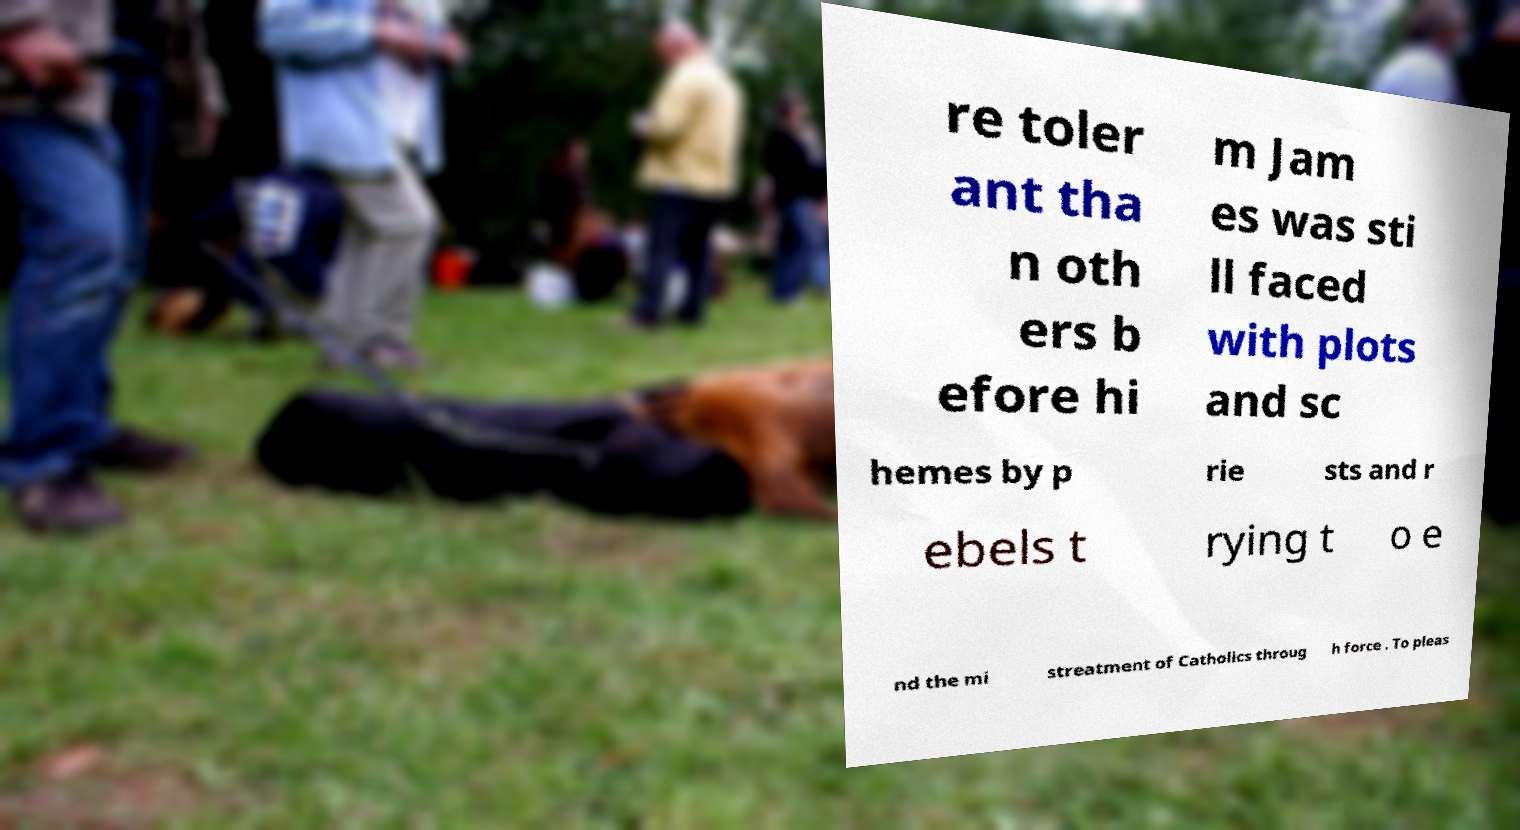For documentation purposes, I need the text within this image transcribed. Could you provide that? re toler ant tha n oth ers b efore hi m Jam es was sti ll faced with plots and sc hemes by p rie sts and r ebels t rying t o e nd the mi streatment of Catholics throug h force . To pleas 